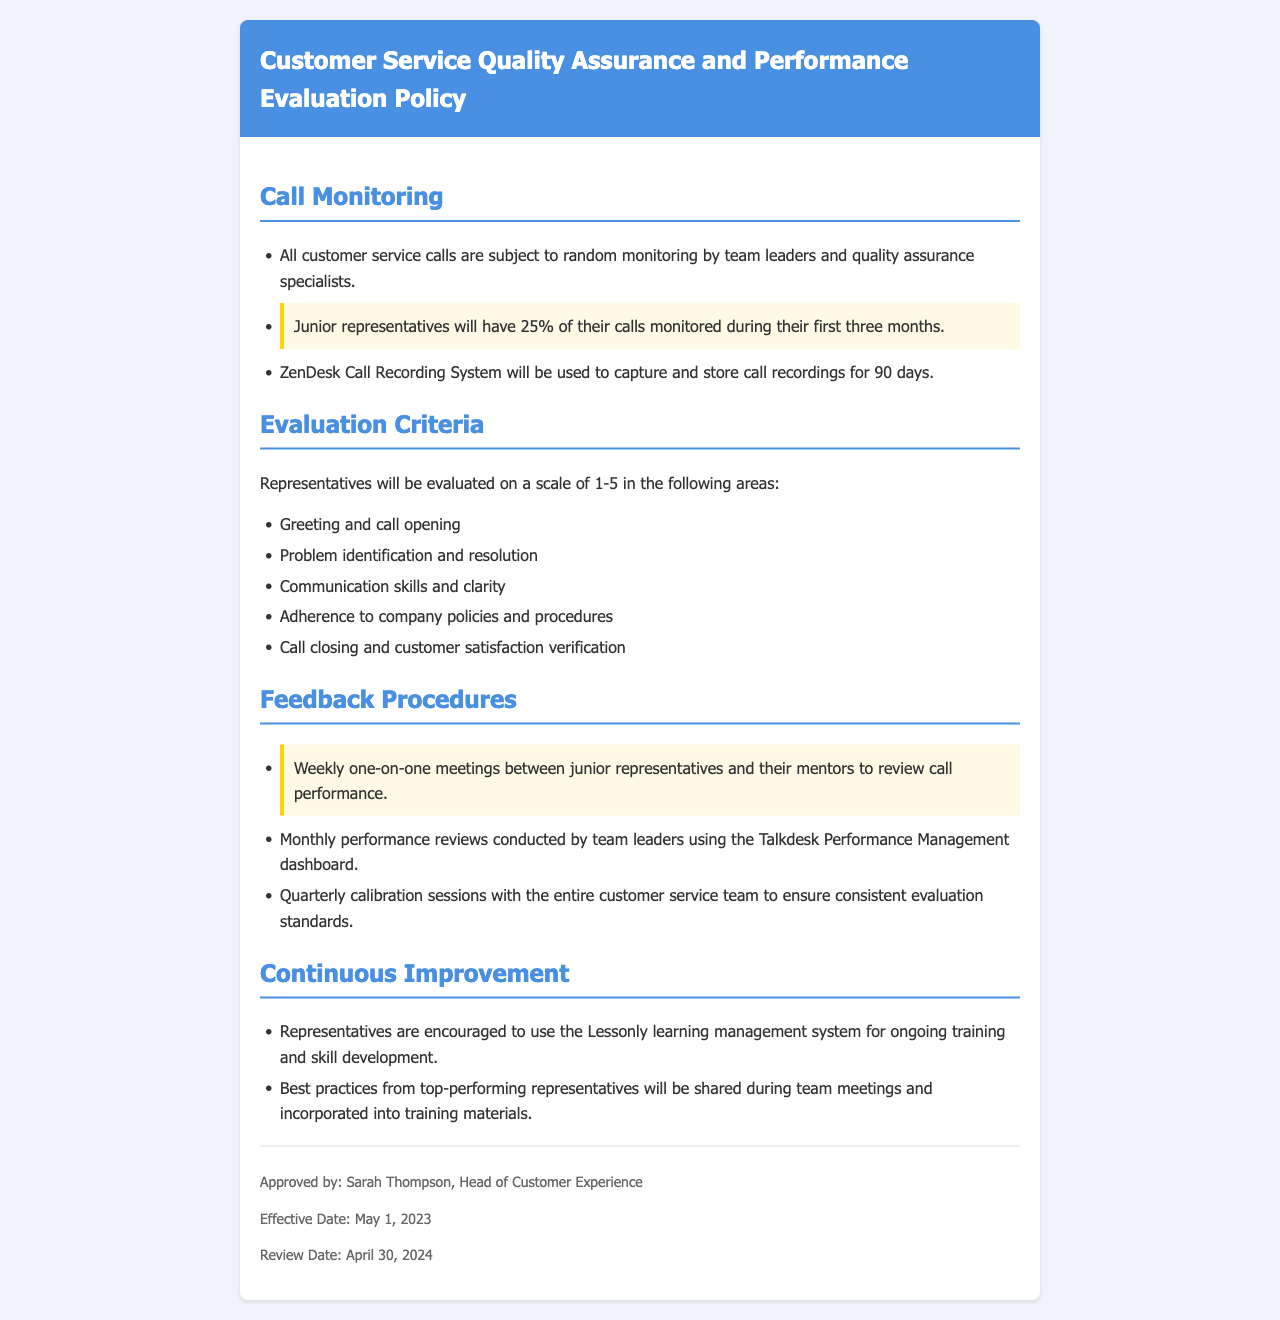What percentage of junior representative calls are monitored? The document states that junior representatives will have 25% of their calls monitored during their first three months.
Answer: 25% What system is used for call recording? The document specifies that the ZenDesk Call Recording System will be used to capture and store call recordings for 90 days.
Answer: ZenDesk Call Recording System What scale is used for evaluating representatives? The evaluation criteria are on a scale from 1 to 5.
Answer: 1-5 How often do junior representatives meet with their mentors? The document mentions weekly one-on-one meetings between junior representatives and their mentors to review call performance.
Answer: Weekly Who approves the Quality Assurance policy? The document identifies Sarah Thompson as the approver and Head of Customer Experience.
Answer: Sarah Thompson What is the effective date of the policy? The document states that the effective date is May 1, 2023.
Answer: May 1, 2023 What type of evaluations are conducted monthly? The document specifies that monthly performance reviews are conducted by team leaders using the Talkdesk Performance Management dashboard.
Answer: Performance reviews How are best practices shared among representatives? The document mentions that best practices from top-performing representatives will be shared during team meetings.
Answer: Team meetings 